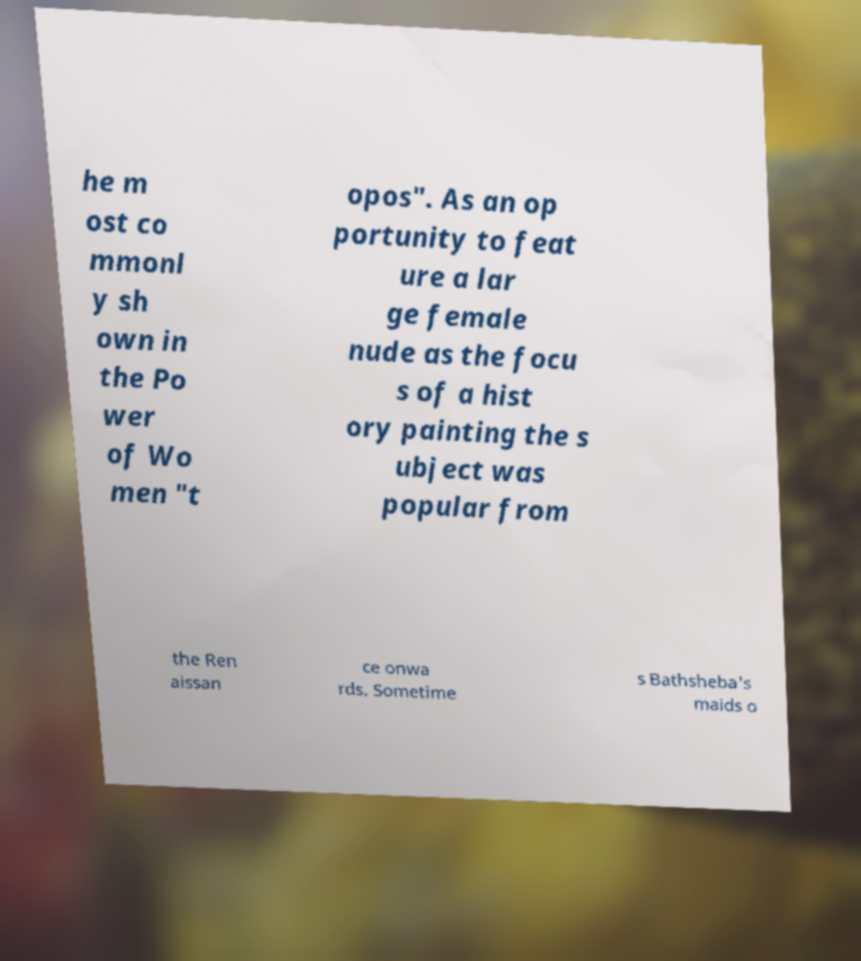Can you accurately transcribe the text from the provided image for me? he m ost co mmonl y sh own in the Po wer of Wo men "t opos". As an op portunity to feat ure a lar ge female nude as the focu s of a hist ory painting the s ubject was popular from the Ren aissan ce onwa rds. Sometime s Bathsheba's maids o 